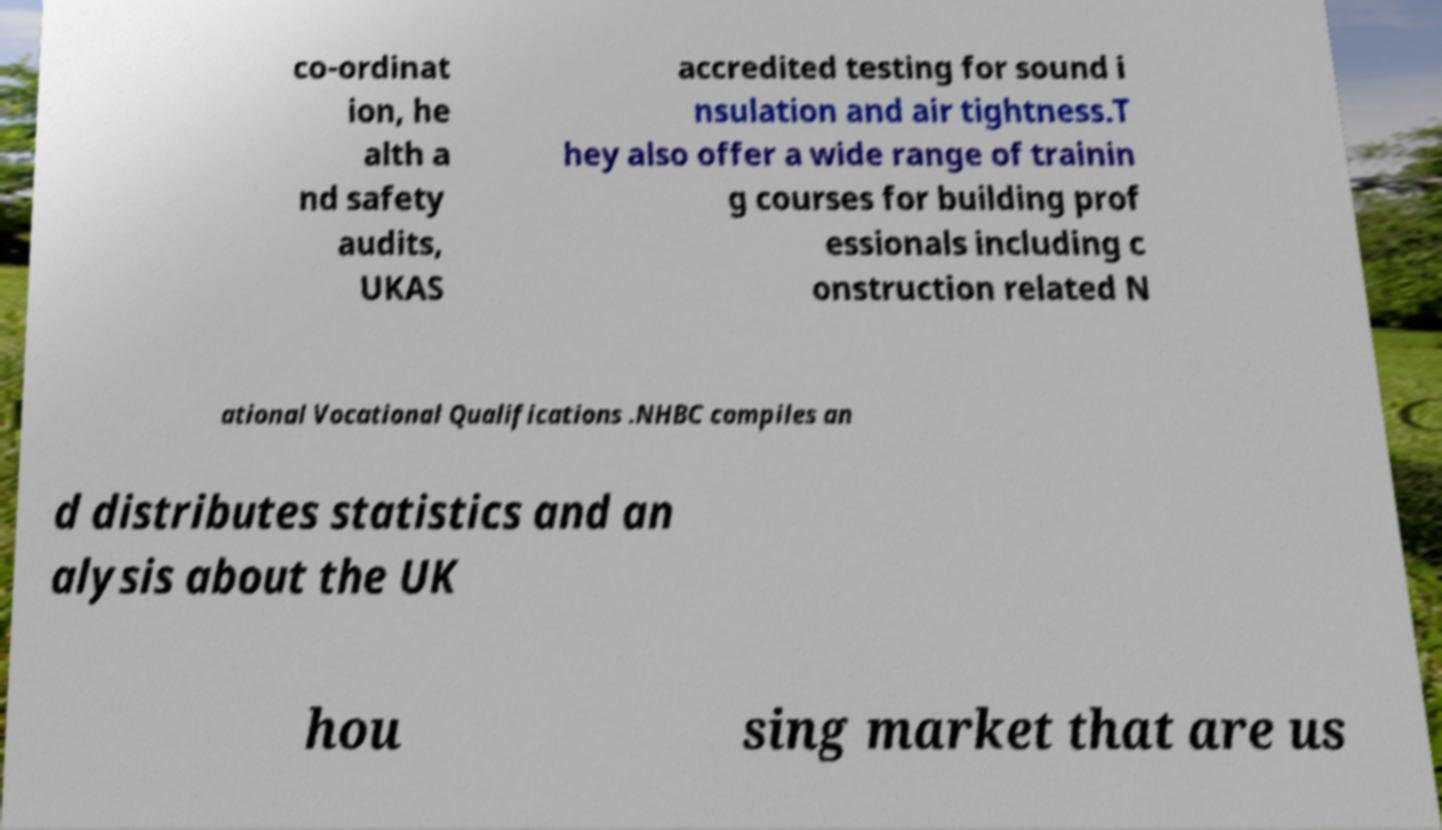Can you accurately transcribe the text from the provided image for me? co-ordinat ion, he alth a nd safety audits, UKAS accredited testing for sound i nsulation and air tightness.T hey also offer a wide range of trainin g courses for building prof essionals including c onstruction related N ational Vocational Qualifications .NHBC compiles an d distributes statistics and an alysis about the UK hou sing market that are us 